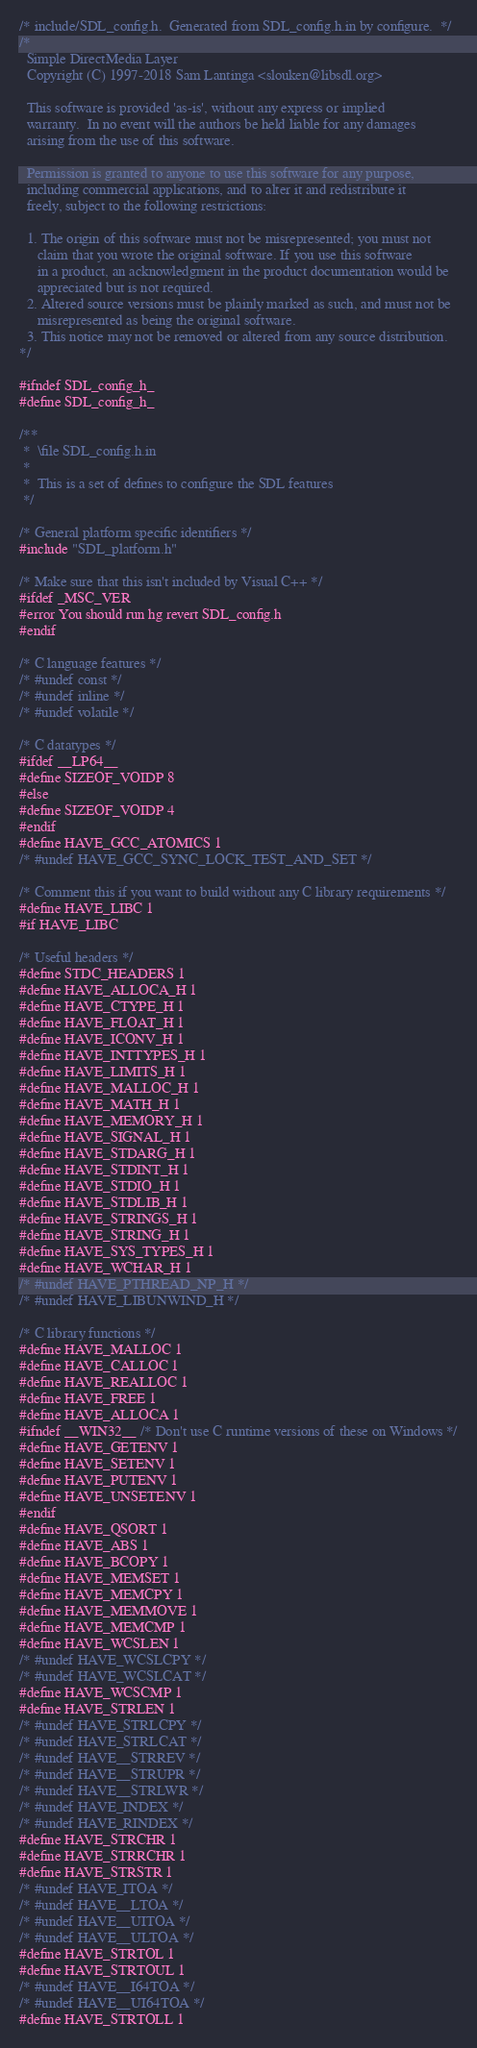Convert code to text. <code><loc_0><loc_0><loc_500><loc_500><_C_>/* include/SDL_config.h.  Generated from SDL_config.h.in by configure.  */
/*
  Simple DirectMedia Layer
  Copyright (C) 1997-2018 Sam Lantinga <slouken@libsdl.org>

  This software is provided 'as-is', without any express or implied
  warranty.  In no event will the authors be held liable for any damages
  arising from the use of this software.

  Permission is granted to anyone to use this software for any purpose,
  including commercial applications, and to alter it and redistribute it
  freely, subject to the following restrictions:

  1. The origin of this software must not be misrepresented; you must not
     claim that you wrote the original software. If you use this software
     in a product, an acknowledgment in the product documentation would be
     appreciated but is not required.
  2. Altered source versions must be plainly marked as such, and must not be
     misrepresented as being the original software.
  3. This notice may not be removed or altered from any source distribution.
*/

#ifndef SDL_config_h_
#define SDL_config_h_

/**
 *  \file SDL_config.h.in
 *
 *  This is a set of defines to configure the SDL features
 */

/* General platform specific identifiers */
#include "SDL_platform.h"

/* Make sure that this isn't included by Visual C++ */
#ifdef _MSC_VER
#error You should run hg revert SDL_config.h 
#endif

/* C language features */
/* #undef const */
/* #undef inline */
/* #undef volatile */

/* C datatypes */
#ifdef __LP64__
#define SIZEOF_VOIDP 8
#else
#define SIZEOF_VOIDP 4
#endif
#define HAVE_GCC_ATOMICS 1
/* #undef HAVE_GCC_SYNC_LOCK_TEST_AND_SET */

/* Comment this if you want to build without any C library requirements */
#define HAVE_LIBC 1
#if HAVE_LIBC

/* Useful headers */
#define STDC_HEADERS 1
#define HAVE_ALLOCA_H 1
#define HAVE_CTYPE_H 1
#define HAVE_FLOAT_H 1
#define HAVE_ICONV_H 1
#define HAVE_INTTYPES_H 1
#define HAVE_LIMITS_H 1
#define HAVE_MALLOC_H 1
#define HAVE_MATH_H 1
#define HAVE_MEMORY_H 1
#define HAVE_SIGNAL_H 1
#define HAVE_STDARG_H 1
#define HAVE_STDINT_H 1
#define HAVE_STDIO_H 1
#define HAVE_STDLIB_H 1
#define HAVE_STRINGS_H 1
#define HAVE_STRING_H 1
#define HAVE_SYS_TYPES_H 1
#define HAVE_WCHAR_H 1
/* #undef HAVE_PTHREAD_NP_H */
/* #undef HAVE_LIBUNWIND_H */

/* C library functions */
#define HAVE_MALLOC 1
#define HAVE_CALLOC 1
#define HAVE_REALLOC 1
#define HAVE_FREE 1
#define HAVE_ALLOCA 1
#ifndef __WIN32__ /* Don't use C runtime versions of these on Windows */
#define HAVE_GETENV 1
#define HAVE_SETENV 1
#define HAVE_PUTENV 1
#define HAVE_UNSETENV 1
#endif
#define HAVE_QSORT 1
#define HAVE_ABS 1
#define HAVE_BCOPY 1
#define HAVE_MEMSET 1
#define HAVE_MEMCPY 1
#define HAVE_MEMMOVE 1
#define HAVE_MEMCMP 1
#define HAVE_WCSLEN 1
/* #undef HAVE_WCSLCPY */
/* #undef HAVE_WCSLCAT */
#define HAVE_WCSCMP 1
#define HAVE_STRLEN 1
/* #undef HAVE_STRLCPY */
/* #undef HAVE_STRLCAT */
/* #undef HAVE__STRREV */
/* #undef HAVE__STRUPR */
/* #undef HAVE__STRLWR */
/* #undef HAVE_INDEX */
/* #undef HAVE_RINDEX */
#define HAVE_STRCHR 1
#define HAVE_STRRCHR 1
#define HAVE_STRSTR 1
/* #undef HAVE_ITOA */
/* #undef HAVE__LTOA */
/* #undef HAVE__UITOA */
/* #undef HAVE__ULTOA */
#define HAVE_STRTOL 1
#define HAVE_STRTOUL 1
/* #undef HAVE__I64TOA */
/* #undef HAVE__UI64TOA */
#define HAVE_STRTOLL 1</code> 